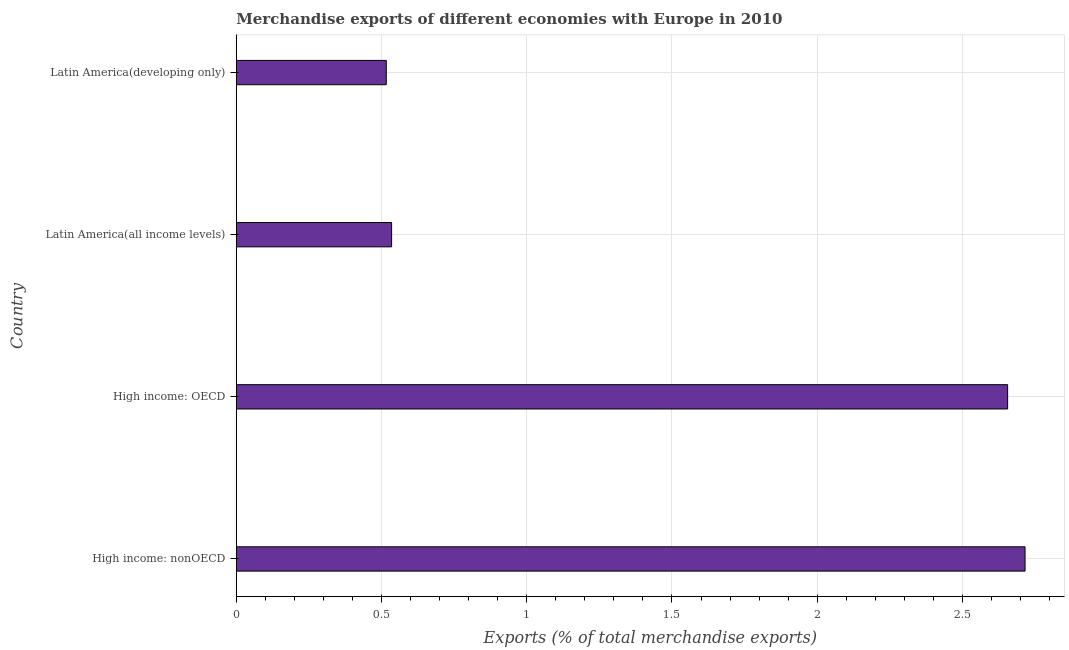What is the title of the graph?
Make the answer very short. Merchandise exports of different economies with Europe in 2010. What is the label or title of the X-axis?
Provide a short and direct response. Exports (% of total merchandise exports). What is the label or title of the Y-axis?
Provide a short and direct response. Country. What is the merchandise exports in Latin America(developing only)?
Provide a succinct answer. 0.52. Across all countries, what is the maximum merchandise exports?
Give a very brief answer. 2.72. Across all countries, what is the minimum merchandise exports?
Make the answer very short. 0.52. In which country was the merchandise exports maximum?
Offer a terse response. High income: nonOECD. In which country was the merchandise exports minimum?
Offer a very short reply. Latin America(developing only). What is the sum of the merchandise exports?
Provide a short and direct response. 6.42. What is the difference between the merchandise exports in High income: OECD and Latin America(developing only)?
Keep it short and to the point. 2.14. What is the average merchandise exports per country?
Provide a short and direct response. 1.61. What is the median merchandise exports?
Offer a very short reply. 1.6. What is the ratio of the merchandise exports in High income: nonOECD to that in Latin America(all income levels)?
Provide a short and direct response. 5.08. Is the merchandise exports in High income: OECD less than that in Latin America(all income levels)?
Your response must be concise. No. Is the difference between the merchandise exports in High income: nonOECD and Latin America(developing only) greater than the difference between any two countries?
Offer a terse response. Yes. What is the difference between the highest and the second highest merchandise exports?
Ensure brevity in your answer.  0.06. What is the difference between the highest and the lowest merchandise exports?
Ensure brevity in your answer.  2.2. Are all the bars in the graph horizontal?
Make the answer very short. Yes. Are the values on the major ticks of X-axis written in scientific E-notation?
Give a very brief answer. No. What is the Exports (% of total merchandise exports) in High income: nonOECD?
Your response must be concise. 2.72. What is the Exports (% of total merchandise exports) in High income: OECD?
Provide a short and direct response. 2.66. What is the Exports (% of total merchandise exports) of Latin America(all income levels)?
Ensure brevity in your answer.  0.53. What is the Exports (% of total merchandise exports) of Latin America(developing only)?
Give a very brief answer. 0.52. What is the difference between the Exports (% of total merchandise exports) in High income: nonOECD and High income: OECD?
Provide a short and direct response. 0.06. What is the difference between the Exports (% of total merchandise exports) in High income: nonOECD and Latin America(all income levels)?
Make the answer very short. 2.18. What is the difference between the Exports (% of total merchandise exports) in High income: nonOECD and Latin America(developing only)?
Your answer should be very brief. 2.2. What is the difference between the Exports (% of total merchandise exports) in High income: OECD and Latin America(all income levels)?
Give a very brief answer. 2.12. What is the difference between the Exports (% of total merchandise exports) in High income: OECD and Latin America(developing only)?
Give a very brief answer. 2.14. What is the difference between the Exports (% of total merchandise exports) in Latin America(all income levels) and Latin America(developing only)?
Offer a terse response. 0.02. What is the ratio of the Exports (% of total merchandise exports) in High income: nonOECD to that in High income: OECD?
Provide a short and direct response. 1.02. What is the ratio of the Exports (% of total merchandise exports) in High income: nonOECD to that in Latin America(all income levels)?
Offer a very short reply. 5.08. What is the ratio of the Exports (% of total merchandise exports) in High income: nonOECD to that in Latin America(developing only)?
Your response must be concise. 5.26. What is the ratio of the Exports (% of total merchandise exports) in High income: OECD to that in Latin America(all income levels)?
Your response must be concise. 4.96. What is the ratio of the Exports (% of total merchandise exports) in High income: OECD to that in Latin America(developing only)?
Your answer should be compact. 5.14. What is the ratio of the Exports (% of total merchandise exports) in Latin America(all income levels) to that in Latin America(developing only)?
Make the answer very short. 1.04. 